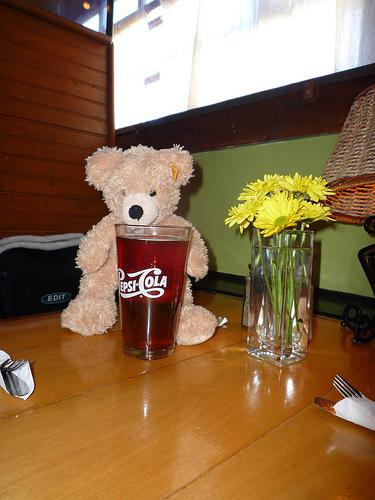Question: how many lamps are on the table?
Choices:
A. 2.
B. 1.
C. 3.
D. 4.
Answer with the letter. Answer: B Question: who is behind the drink?
Choices:
A. The teddy bear.
B. The toy soldier.
C. The barbie doll.
D. The nutcracker.
Answer with the letter. Answer: A Question: what color is the drink?
Choices:
A. Red.
B. Green.
C. White.
D. Blue.
Answer with the letter. Answer: A Question: where are the flowers?
Choices:
A. In the vase.
B. In the ground.
C. The child's hand.
D. Wrapped in paper.
Answer with the letter. Answer: A Question: where was the picture taken from?
Choices:
A. Bedroom.
B. The inside.
C. Bathroom.
D. Backyard.
Answer with the letter. Answer: B 